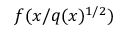<formula> <loc_0><loc_0><loc_500><loc_500>f ( x / q ( x ) ^ { 1 / 2 } )</formula> 